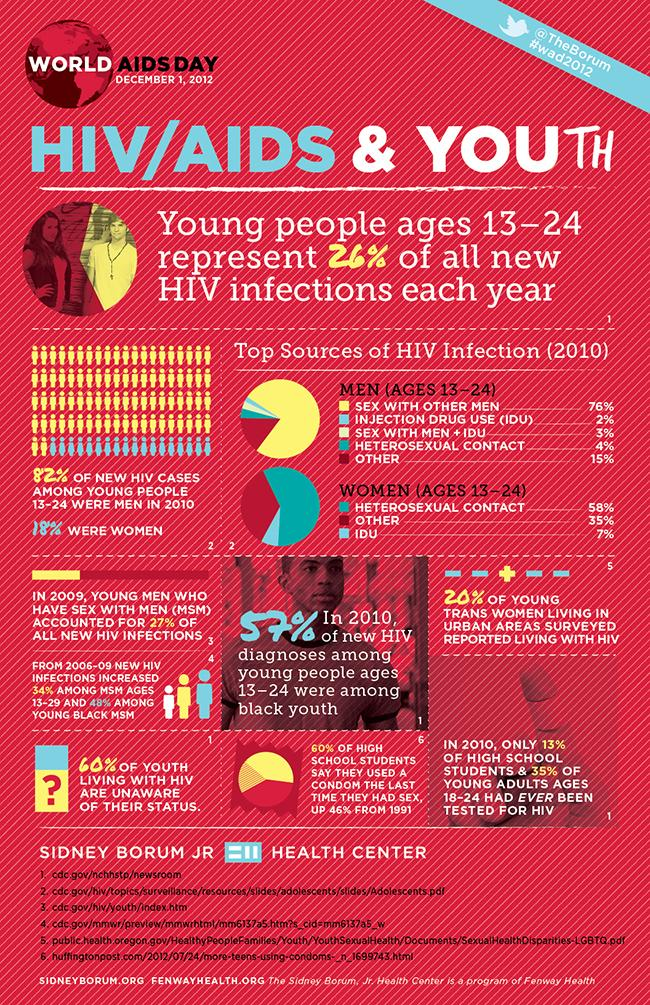Identify some key points in this picture. In 2010, 58% of women in the age group of 13-24 had heterosexual contact as the source of their HIV infection. In 2010, among young people aged 13 to 24, women accounted for 18% of all new HIV cases. In 2010, it was reported that 13% of high school students had ever been tested for HIV. In 2010, approximately 2% of men in the age group of 13-24 had injection drug use (IDU) as the source of HIV infection. In 2010, 82% of new HIV cases among young people aged 13-24 were among males. 